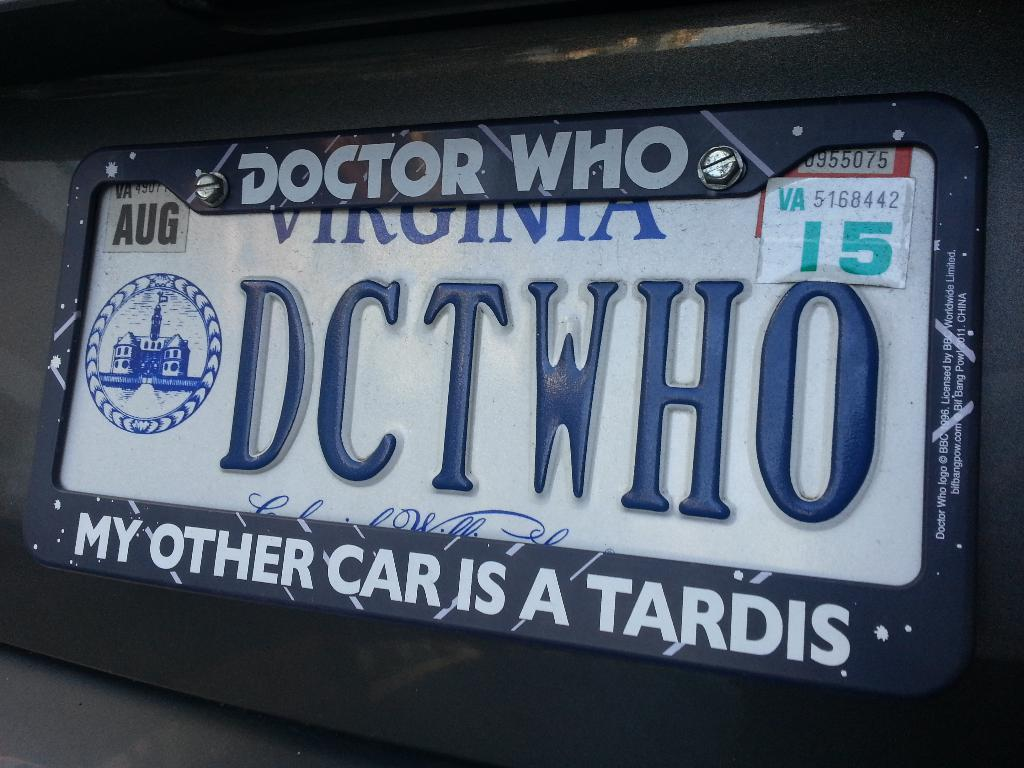<image>
Provide a brief description of the given image. License plate that has a Doctor Who cover from Virginia. 